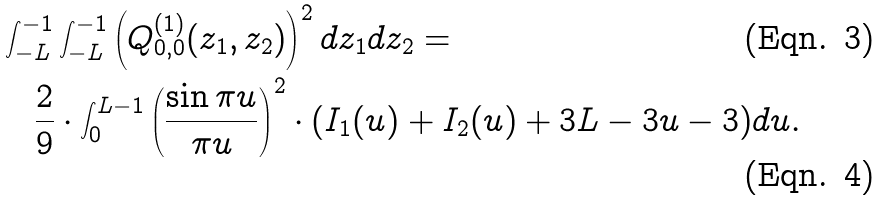Convert formula to latex. <formula><loc_0><loc_0><loc_500><loc_500>& \int ^ { - 1 } _ { - L } \int ^ { - 1 } _ { - L } \left ( Q ^ { ( 1 ) } _ { 0 , 0 } ( z _ { 1 } , z _ { 2 } ) \right ) ^ { 2 } d z _ { 1 } d z _ { 2 } = \\ & \quad \frac { 2 } { 9 } \cdot \int ^ { L - 1 } _ { 0 } \left ( \frac { \sin \pi u } { \pi u } \right ) ^ { 2 } \cdot ( I _ { 1 } ( u ) + I _ { 2 } ( u ) + 3 L - 3 u - 3 ) d u .</formula> 